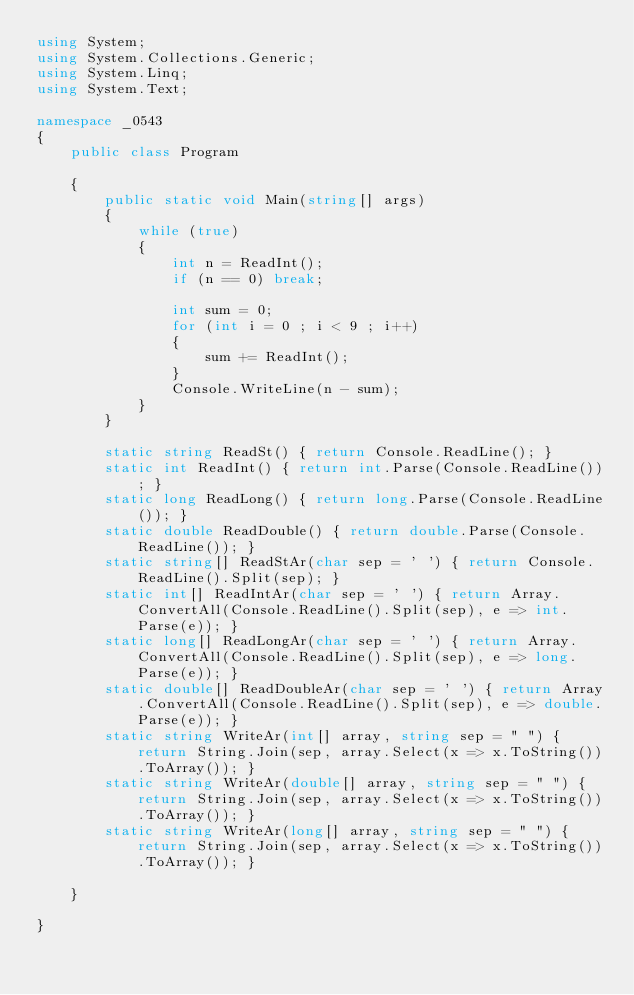<code> <loc_0><loc_0><loc_500><loc_500><_C#_>using System;
using System.Collections.Generic;
using System.Linq;
using System.Text;

namespace _0543
{
    public class Program

    {
        public static void Main(string[] args)
        {            
            while (true)
            {
                int n = ReadInt();
                if (n == 0) break;

                int sum = 0;
                for (int i = 0 ; i < 9 ; i++)
                {
                    sum += ReadInt();
                }
                Console.WriteLine(n - sum);
            }           
        }

        static string ReadSt() { return Console.ReadLine(); }
        static int ReadInt() { return int.Parse(Console.ReadLine()); }
        static long ReadLong() { return long.Parse(Console.ReadLine()); }
        static double ReadDouble() { return double.Parse(Console.ReadLine()); }
        static string[] ReadStAr(char sep = ' ') { return Console.ReadLine().Split(sep); }
        static int[] ReadIntAr(char sep = ' ') { return Array.ConvertAll(Console.ReadLine().Split(sep), e => int.Parse(e)); }
        static long[] ReadLongAr(char sep = ' ') { return Array.ConvertAll(Console.ReadLine().Split(sep), e => long.Parse(e)); }
        static double[] ReadDoubleAr(char sep = ' ') { return Array.ConvertAll(Console.ReadLine().Split(sep), e => double.Parse(e)); }
        static string WriteAr(int[] array, string sep = " ") { return String.Join(sep, array.Select(x => x.ToString()).ToArray()); }
        static string WriteAr(double[] array, string sep = " ") { return String.Join(sep, array.Select(x => x.ToString()).ToArray()); }
        static string WriteAr(long[] array, string sep = " ") { return String.Join(sep, array.Select(x => x.ToString()).ToArray()); }

    }

}

</code> 